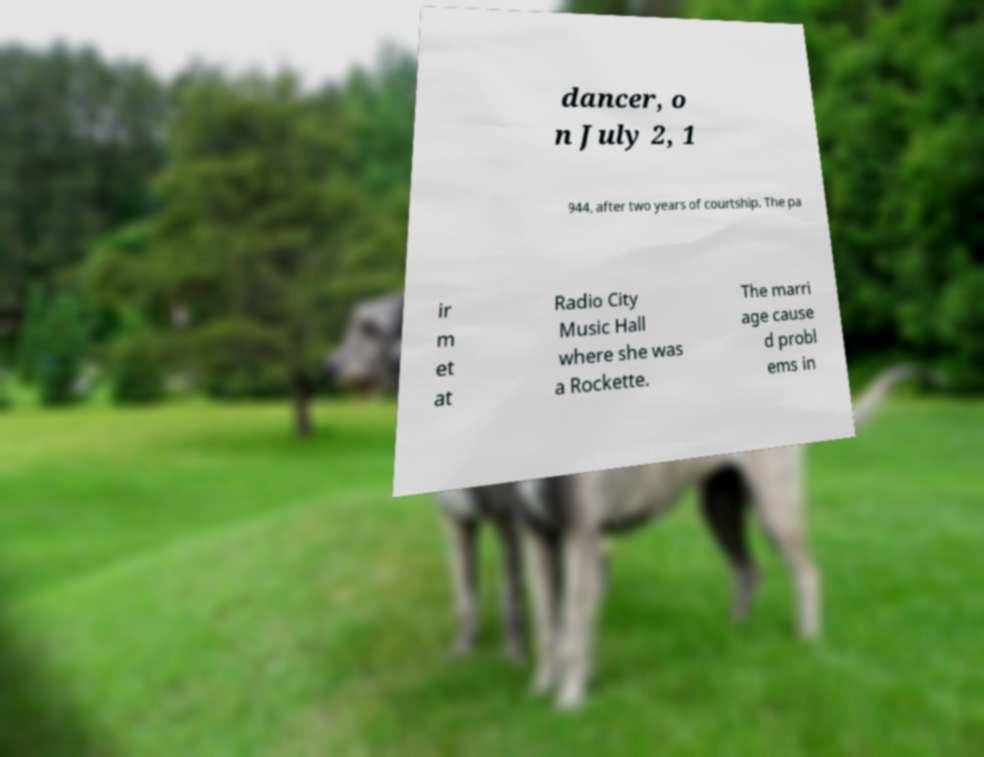I need the written content from this picture converted into text. Can you do that? dancer, o n July 2, 1 944, after two years of courtship. The pa ir m et at Radio City Music Hall where she was a Rockette. The marri age cause d probl ems in 